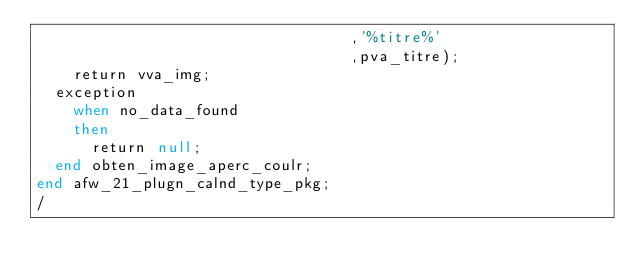Convert code to text. <code><loc_0><loc_0><loc_500><loc_500><_SQL_>                                  ,'%titre%'
                                  ,pva_titre);
    return vva_img;
  exception
    when no_data_found
    then
      return null;
  end obten_image_aperc_coulr;
end afw_21_plugn_calnd_type_pkg;
/
</code> 